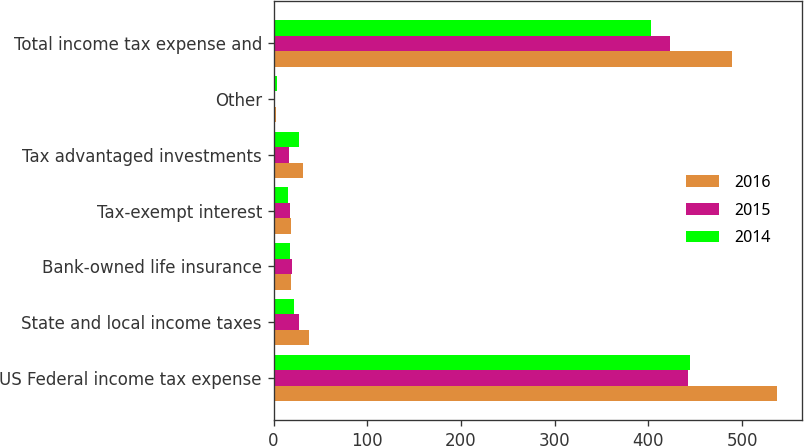Convert chart. <chart><loc_0><loc_0><loc_500><loc_500><stacked_bar_chart><ecel><fcel>US Federal income tax expense<fcel>State and local income taxes<fcel>Bank-owned life insurance<fcel>Tax-exempt interest<fcel>Tax advantaged investments<fcel>Other<fcel>Total income tax expense and<nl><fcel>2016<fcel>537<fcel>38<fcel>19<fcel>19<fcel>31<fcel>3<fcel>489<nl><fcel>2015<fcel>442<fcel>27<fcel>20<fcel>17<fcel>16<fcel>1<fcel>423<nl><fcel>2014<fcel>444<fcel>22<fcel>17<fcel>15<fcel>27<fcel>4<fcel>403<nl></chart> 